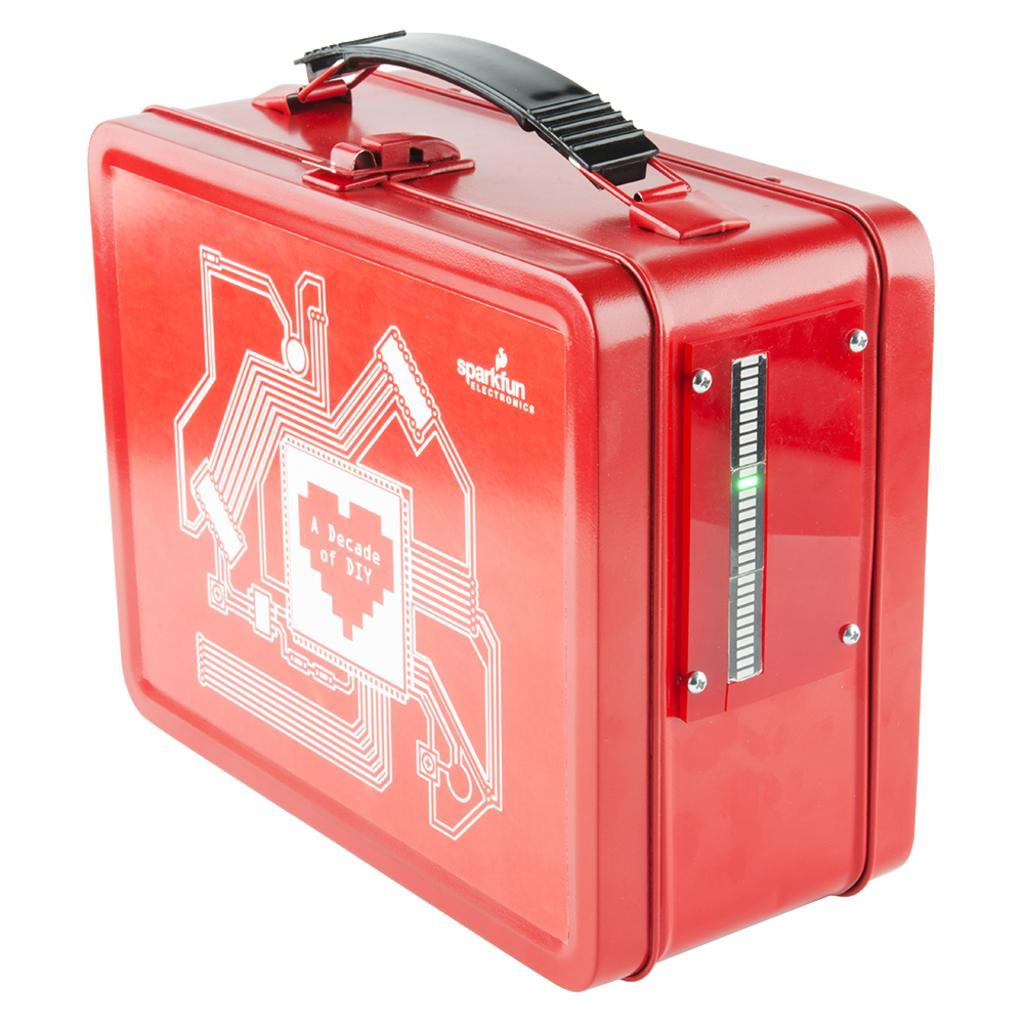What is the color of the box in the image? The box in the image is red. What is attached to the box for carrying purposes? The box has a black handle. Are there any designs on the box? Yes, the box has white designs on it. What name is written on the box? The name "sparkfun" is written on the box. How does the box provide comfort to the people in the image? The image does not depict any people, and the box's purpose is not related to providing comfort. 